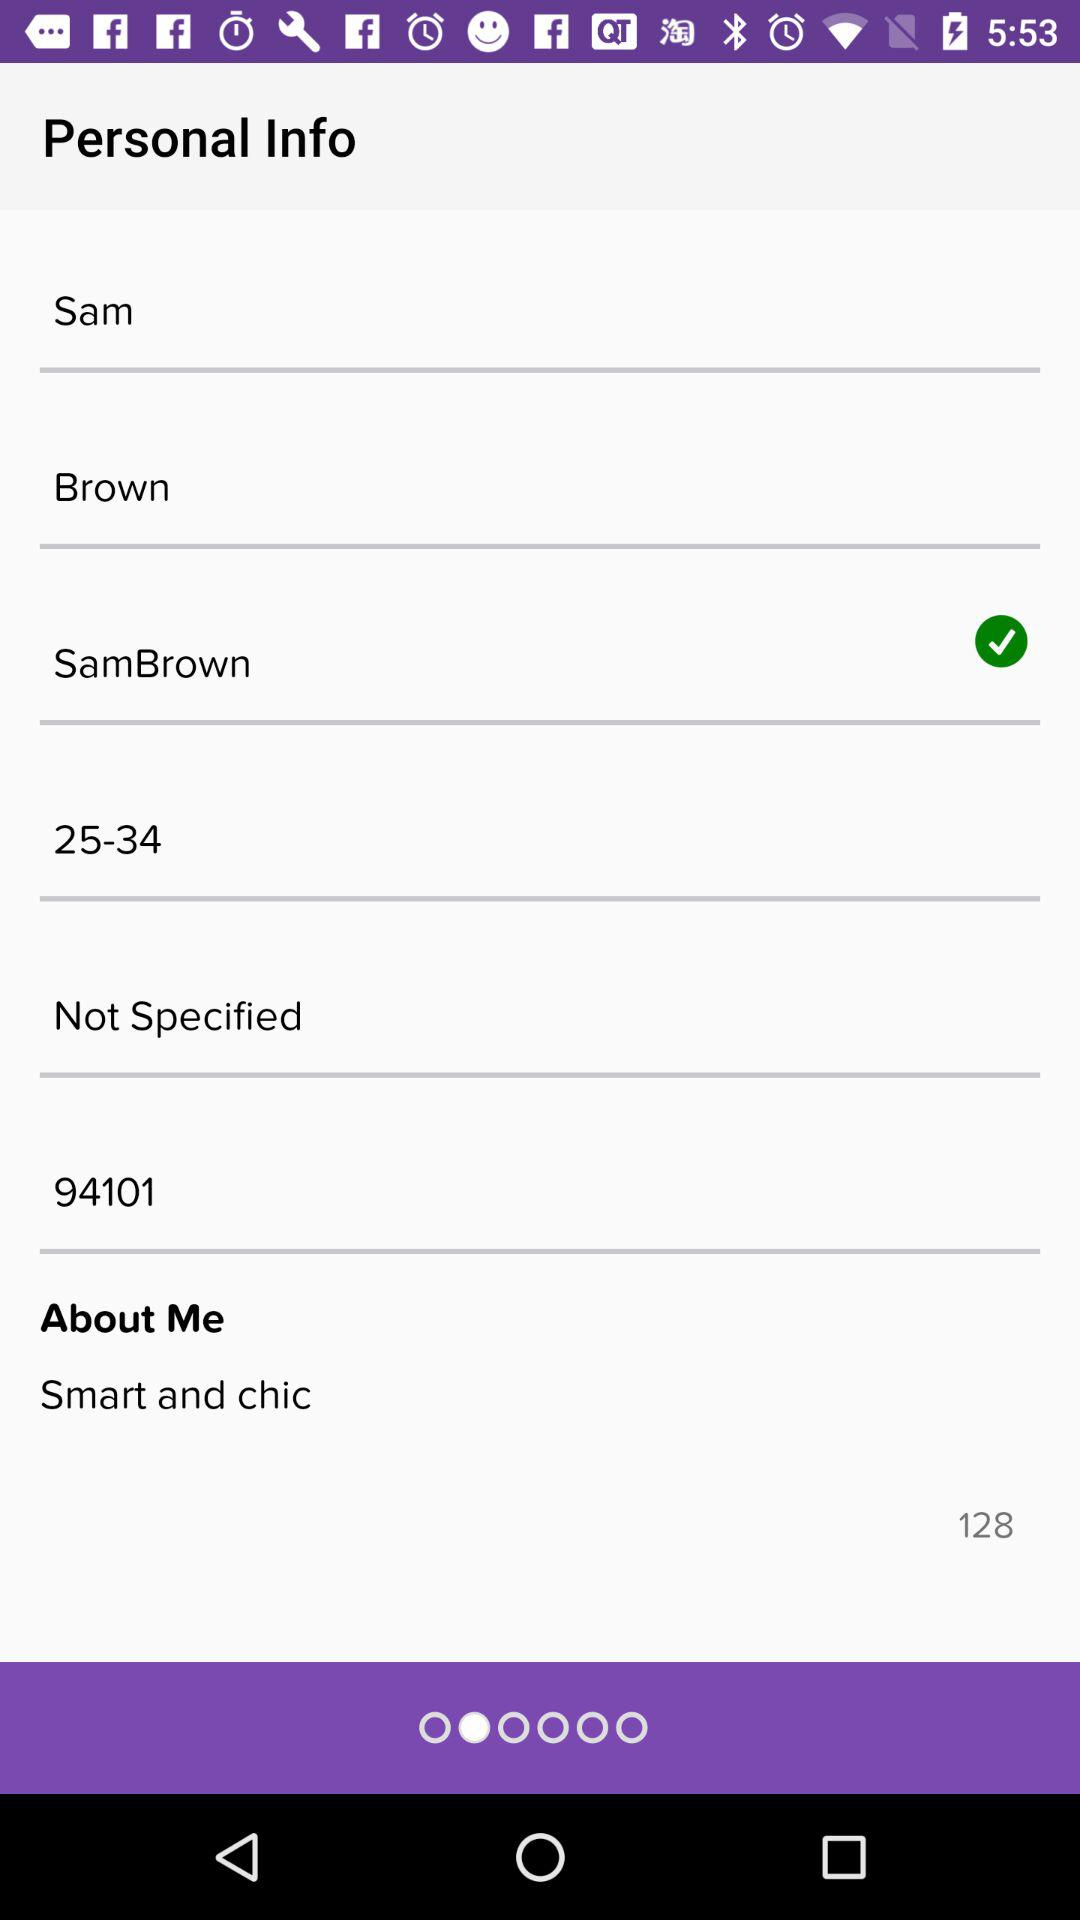What is the name of the person? The name of the person is Sam Brown. 